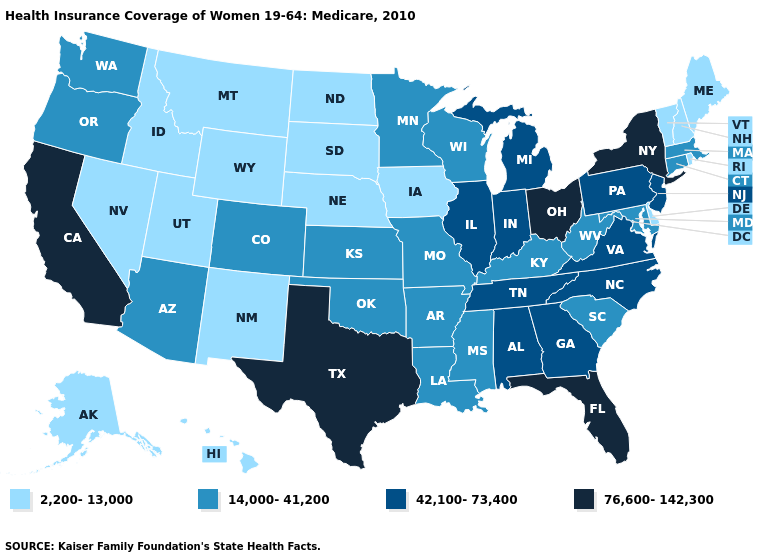What is the lowest value in states that border Missouri?
Concise answer only. 2,200-13,000. Name the states that have a value in the range 14,000-41,200?
Concise answer only. Arizona, Arkansas, Colorado, Connecticut, Kansas, Kentucky, Louisiana, Maryland, Massachusetts, Minnesota, Mississippi, Missouri, Oklahoma, Oregon, South Carolina, Washington, West Virginia, Wisconsin. What is the value of Wisconsin?
Keep it brief. 14,000-41,200. Does Maine have the highest value in the Northeast?
Answer briefly. No. Among the states that border Delaware , which have the highest value?
Quick response, please. New Jersey, Pennsylvania. Among the states that border Alabama , does Florida have the highest value?
Give a very brief answer. Yes. What is the value of New Mexico?
Answer briefly. 2,200-13,000. What is the highest value in the USA?
Be succinct. 76,600-142,300. Name the states that have a value in the range 76,600-142,300?
Write a very short answer. California, Florida, New York, Ohio, Texas. Does the map have missing data?
Answer briefly. No. Is the legend a continuous bar?
Answer briefly. No. Is the legend a continuous bar?
Concise answer only. No. What is the value of Nevada?
Answer briefly. 2,200-13,000. Name the states that have a value in the range 14,000-41,200?
Write a very short answer. Arizona, Arkansas, Colorado, Connecticut, Kansas, Kentucky, Louisiana, Maryland, Massachusetts, Minnesota, Mississippi, Missouri, Oklahoma, Oregon, South Carolina, Washington, West Virginia, Wisconsin. How many symbols are there in the legend?
Give a very brief answer. 4. 